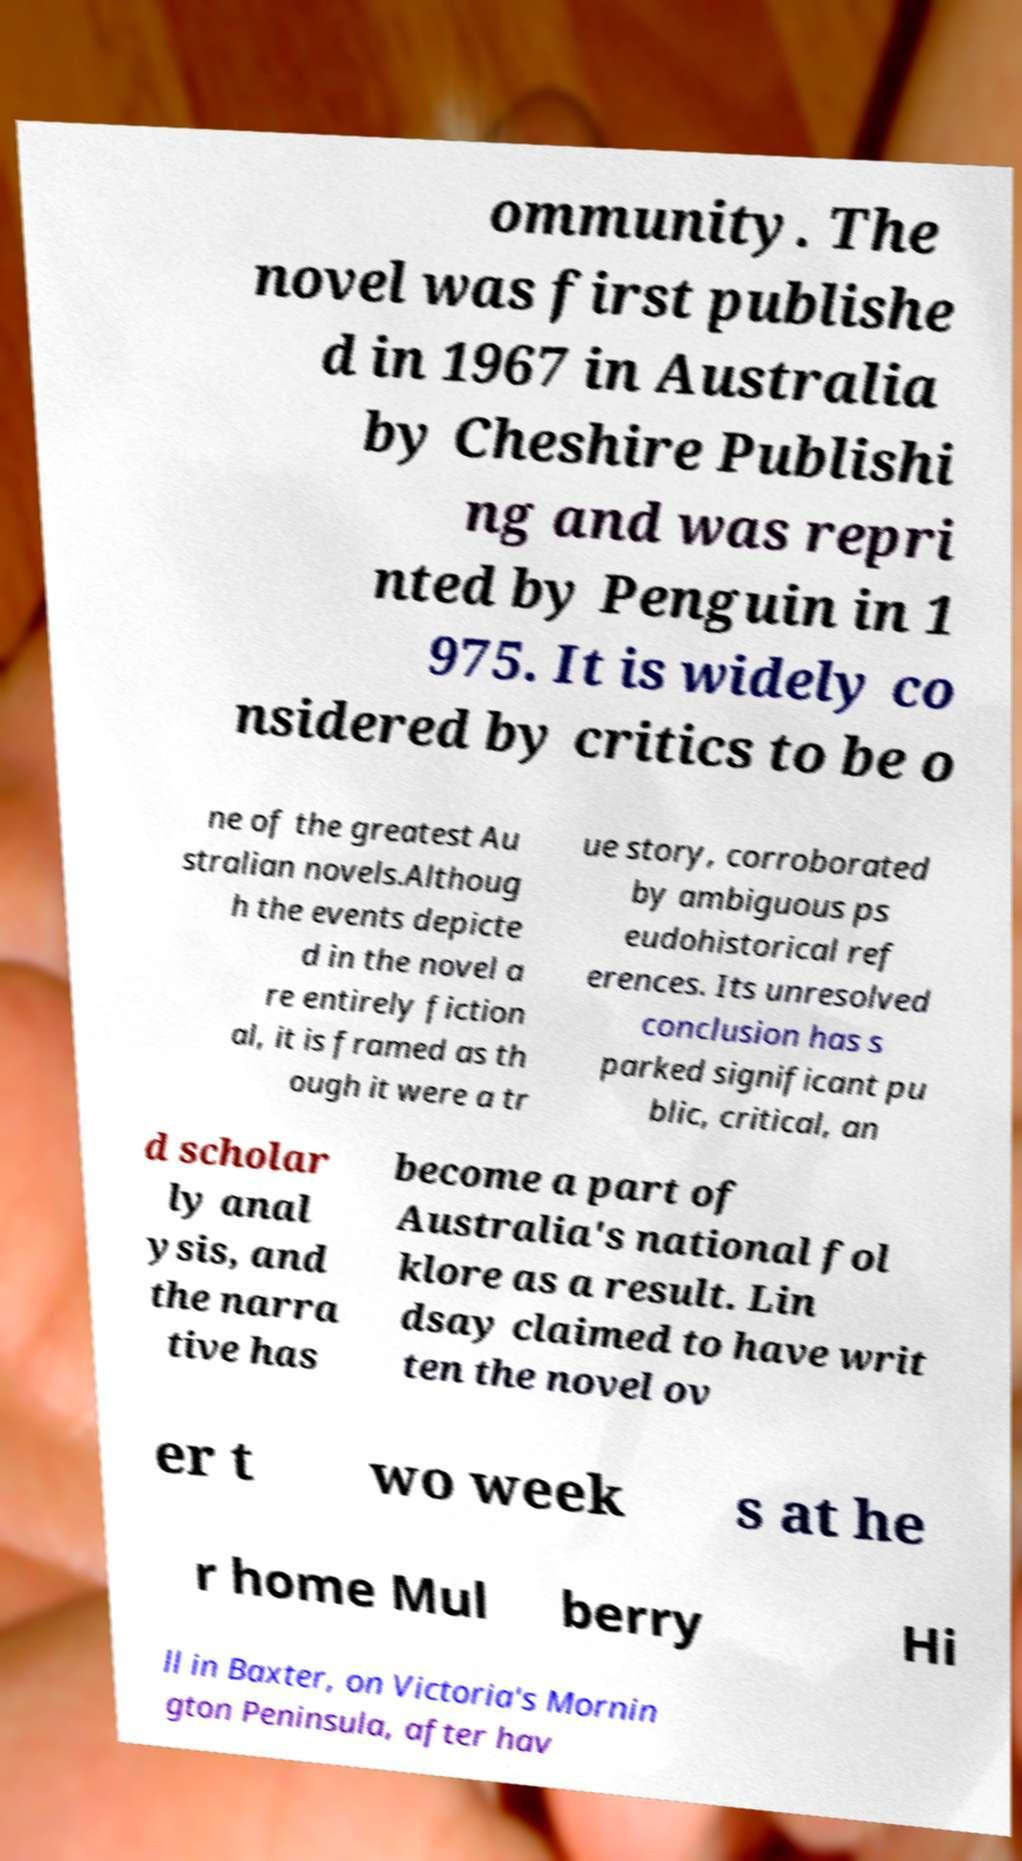Could you extract and type out the text from this image? ommunity. The novel was first publishe d in 1967 in Australia by Cheshire Publishi ng and was repri nted by Penguin in 1 975. It is widely co nsidered by critics to be o ne of the greatest Au stralian novels.Althoug h the events depicte d in the novel a re entirely fiction al, it is framed as th ough it were a tr ue story, corroborated by ambiguous ps eudohistorical ref erences. Its unresolved conclusion has s parked significant pu blic, critical, an d scholar ly anal ysis, and the narra tive has become a part of Australia's national fol klore as a result. Lin dsay claimed to have writ ten the novel ov er t wo week s at he r home Mul berry Hi ll in Baxter, on Victoria's Mornin gton Peninsula, after hav 